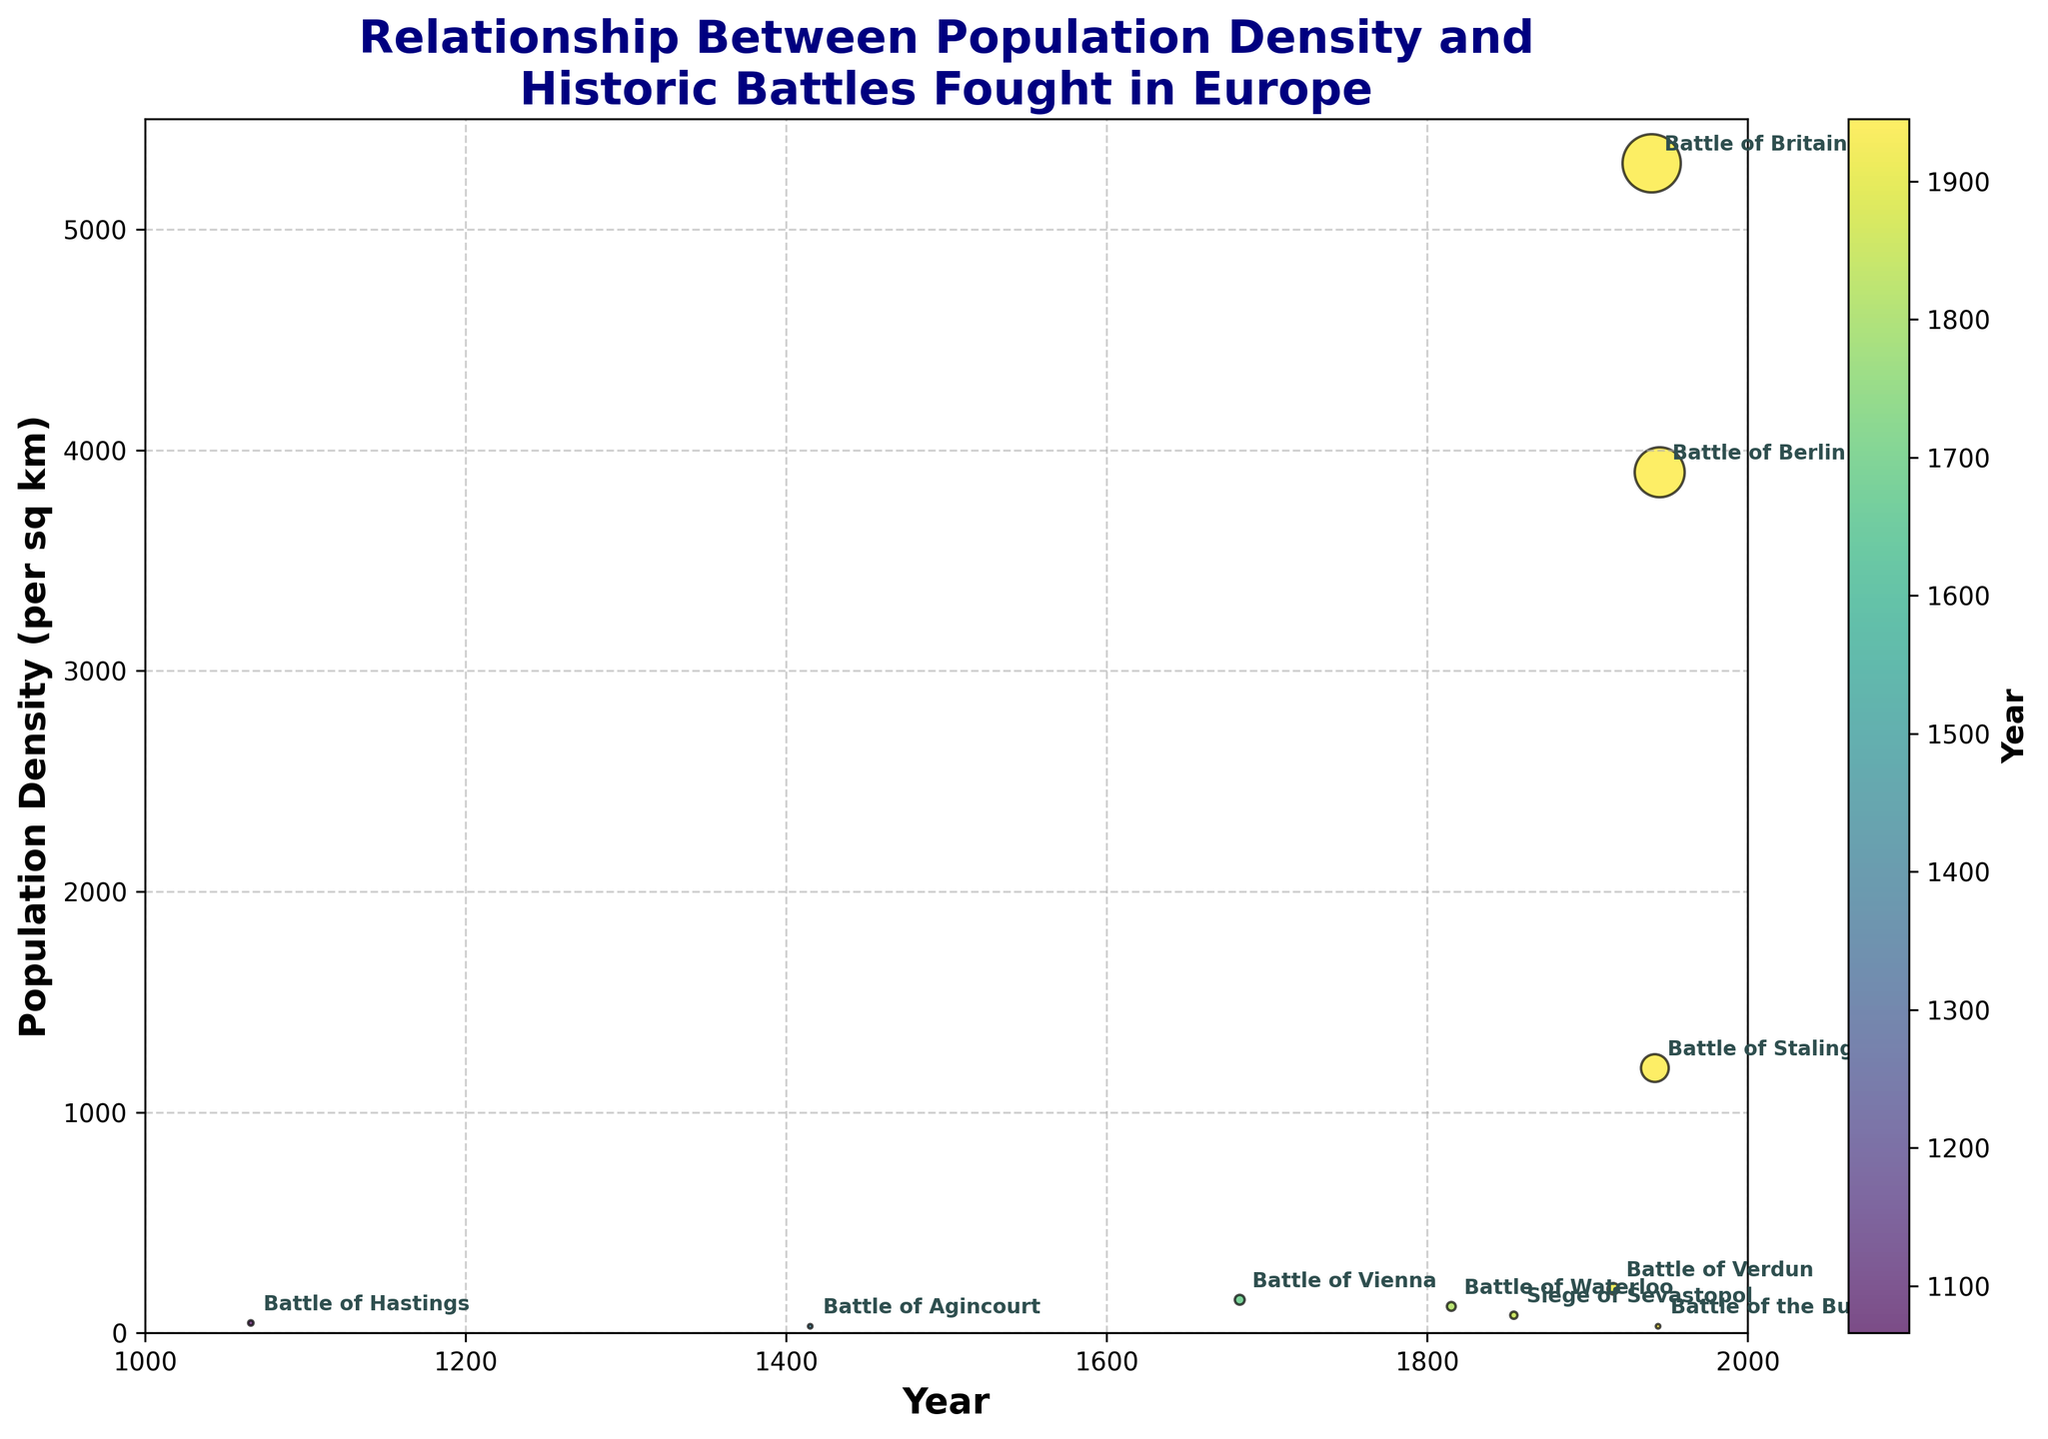What is the title of the figure? The title is displayed at the top of the figure and encompasses the main focus of the plot.
Answer: Relationship Between Population Density and Historic Battles Fought in Europe How many battles are represented in the scatter plot? Each battle is represented as a data point in the scatter plot. By counting the number of data points, one can determine the number of battles.
Answer: 10 Which battle took place in the year 1683? By locating the data point on the scatter plot that corresponds to the year 1683 and checking the annotation next to it, one can identify the related battle.
Answer: Battle of Vienna What is the population density at the Battle of Berlin? Locate the annotation "Battle of Berlin" on the scatter plot and observe its vertical position relative to the Population Density axis.
Answer: 3900 per sq km Which battle has the highest population density? By identifying the data point with the highest vertical position on the scatter plot, which corresponds to the highest population density, one can determine the relevant battle.
Answer: Battle of Britain Which of these battles occurred earlier, the Battle of Agincourt or the Battle of Stalingrad? Compare the horizontal positions of the data points for both battles; the battle corresponding to the leftmost point occurred earlier.
Answer: Battle of Agincourt What is the difference in population density between the Battle of Waterloo and the Battle of Verdun? Find the population densities of the Battle of Waterloo (120) and the Battle of Verdun (200) and subtract the smaller value from the larger one.
Answer: 80 per sq km How many battles happened between the years 1800 and 1900? Count the data points that fall within the horizontal range from 1800 to 1900 on the scatter plot.
Answer: 2 Which battle took place at a location with a population density of 1200 per sq km? Identify the data point that is positioned at 1200 on the Population Density axis and check the associated annotation for the battle name.
Answer: Battle of Stalingrad What is the average population density of all the battles? Sum all the population density values from each battle and divide by the total number of battles. Population densities: 45, 30, 150, 120, 80, 200, 5300, 1200, 30, 3900. Total = 10055. Average = 10055 / 10.
Answer: 1005.5 per sq km 